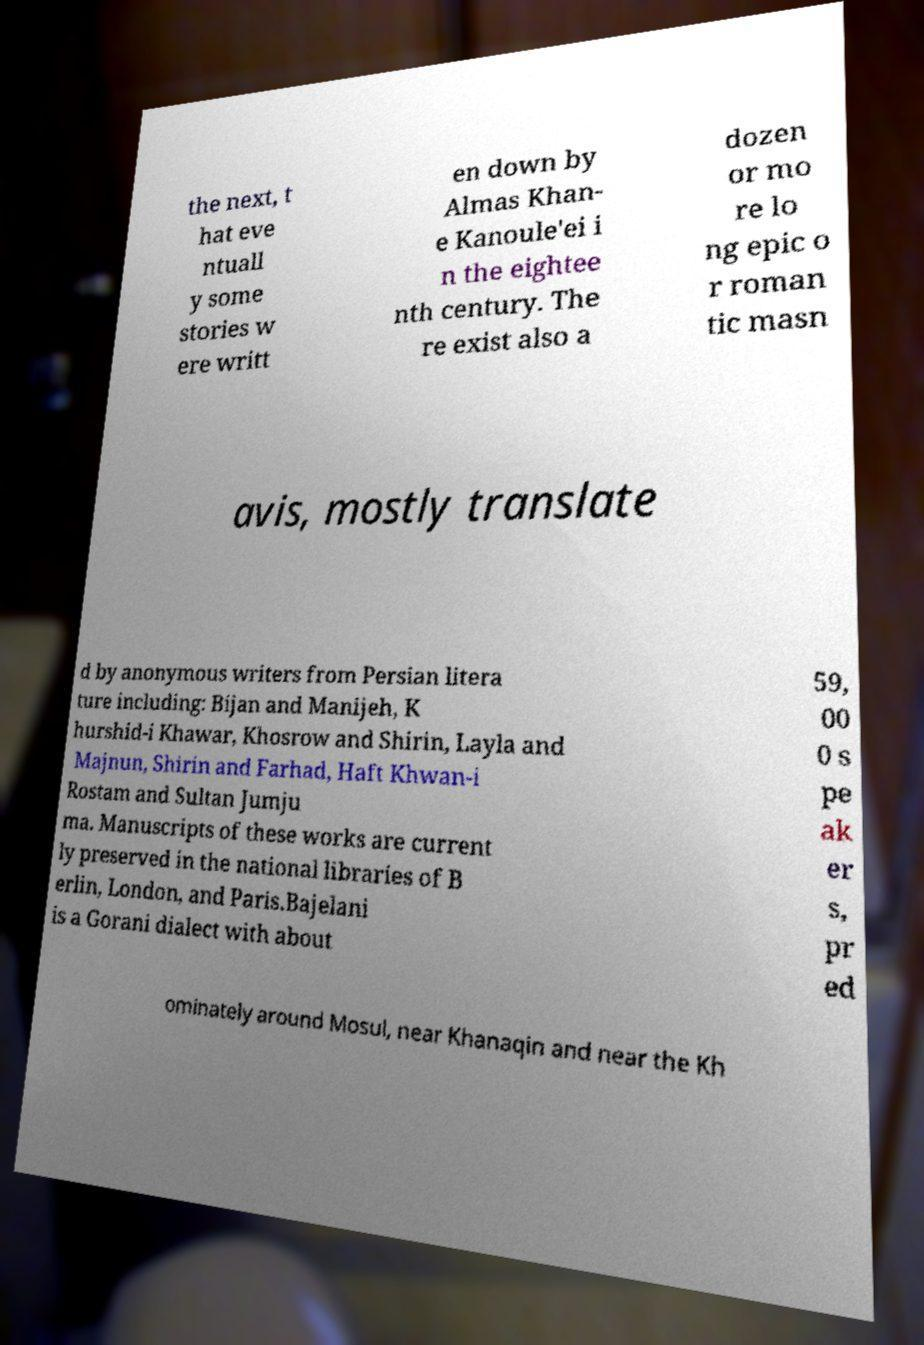What messages or text are displayed in this image? I need them in a readable, typed format. the next, t hat eve ntuall y some stories w ere writt en down by Almas Khan- e Kanoule'ei i n the eightee nth century. The re exist also a dozen or mo re lo ng epic o r roman tic masn avis, mostly translate d by anonymous writers from Persian litera ture including: Bijan and Manijeh, K hurshid-i Khawar, Khosrow and Shirin, Layla and Majnun, Shirin and Farhad, Haft Khwan-i Rostam and Sultan Jumju ma. Manuscripts of these works are current ly preserved in the national libraries of B erlin, London, and Paris.Bajelani is a Gorani dialect with about 59, 00 0 s pe ak er s, pr ed ominately around Mosul, near Khanaqin and near the Kh 